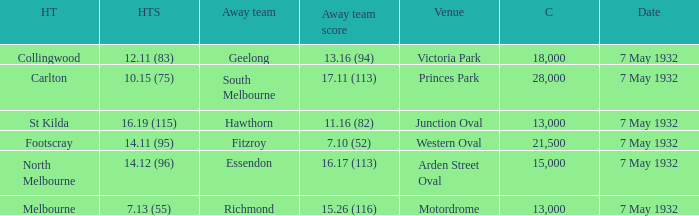What is the biggest gathering with away team score of 1 18000.0. 